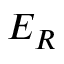Convert formula to latex. <formula><loc_0><loc_0><loc_500><loc_500>E _ { R }</formula> 